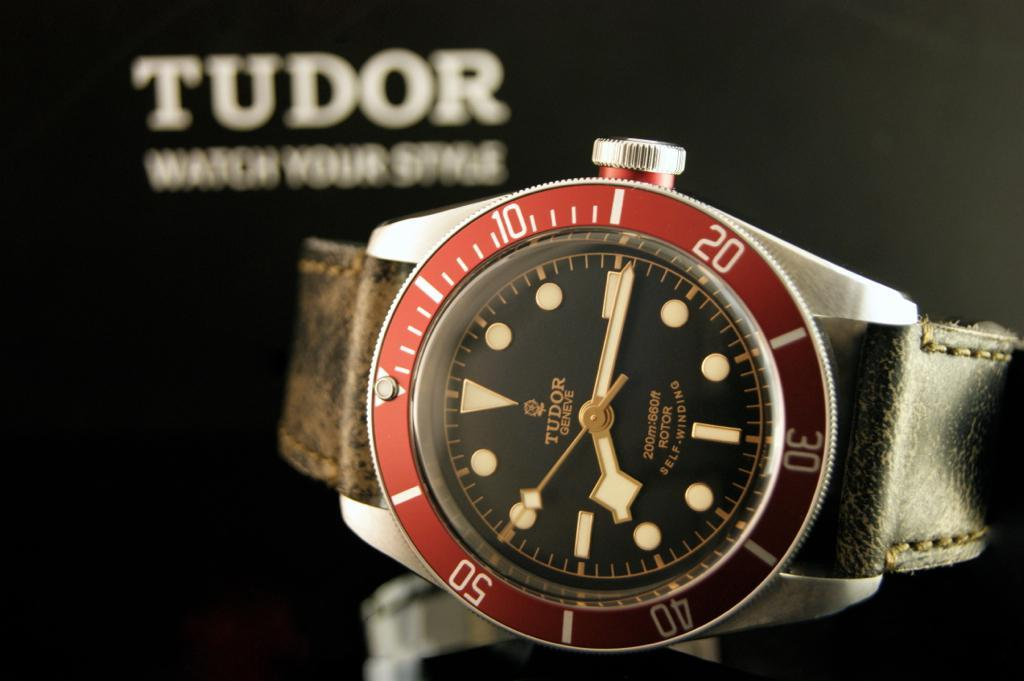<image>
Offer a succinct explanation of the picture presented. A silver Tudor brand watch with a red ring around the outside. 